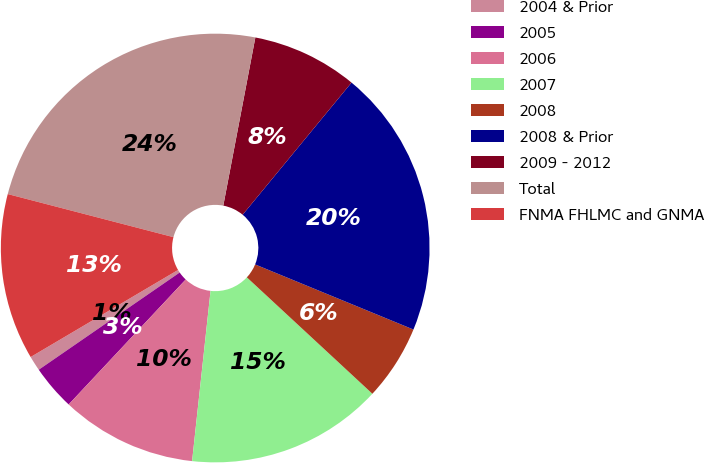Convert chart to OTSL. <chart><loc_0><loc_0><loc_500><loc_500><pie_chart><fcel>2004 & Prior<fcel>2005<fcel>2006<fcel>2007<fcel>2008<fcel>2008 & Prior<fcel>2009 - 2012<fcel>Total<fcel>FNMA FHLMC and GNMA<nl><fcel>1.12%<fcel>3.41%<fcel>10.26%<fcel>14.82%<fcel>5.69%<fcel>20.24%<fcel>7.97%<fcel>23.95%<fcel>12.54%<nl></chart> 